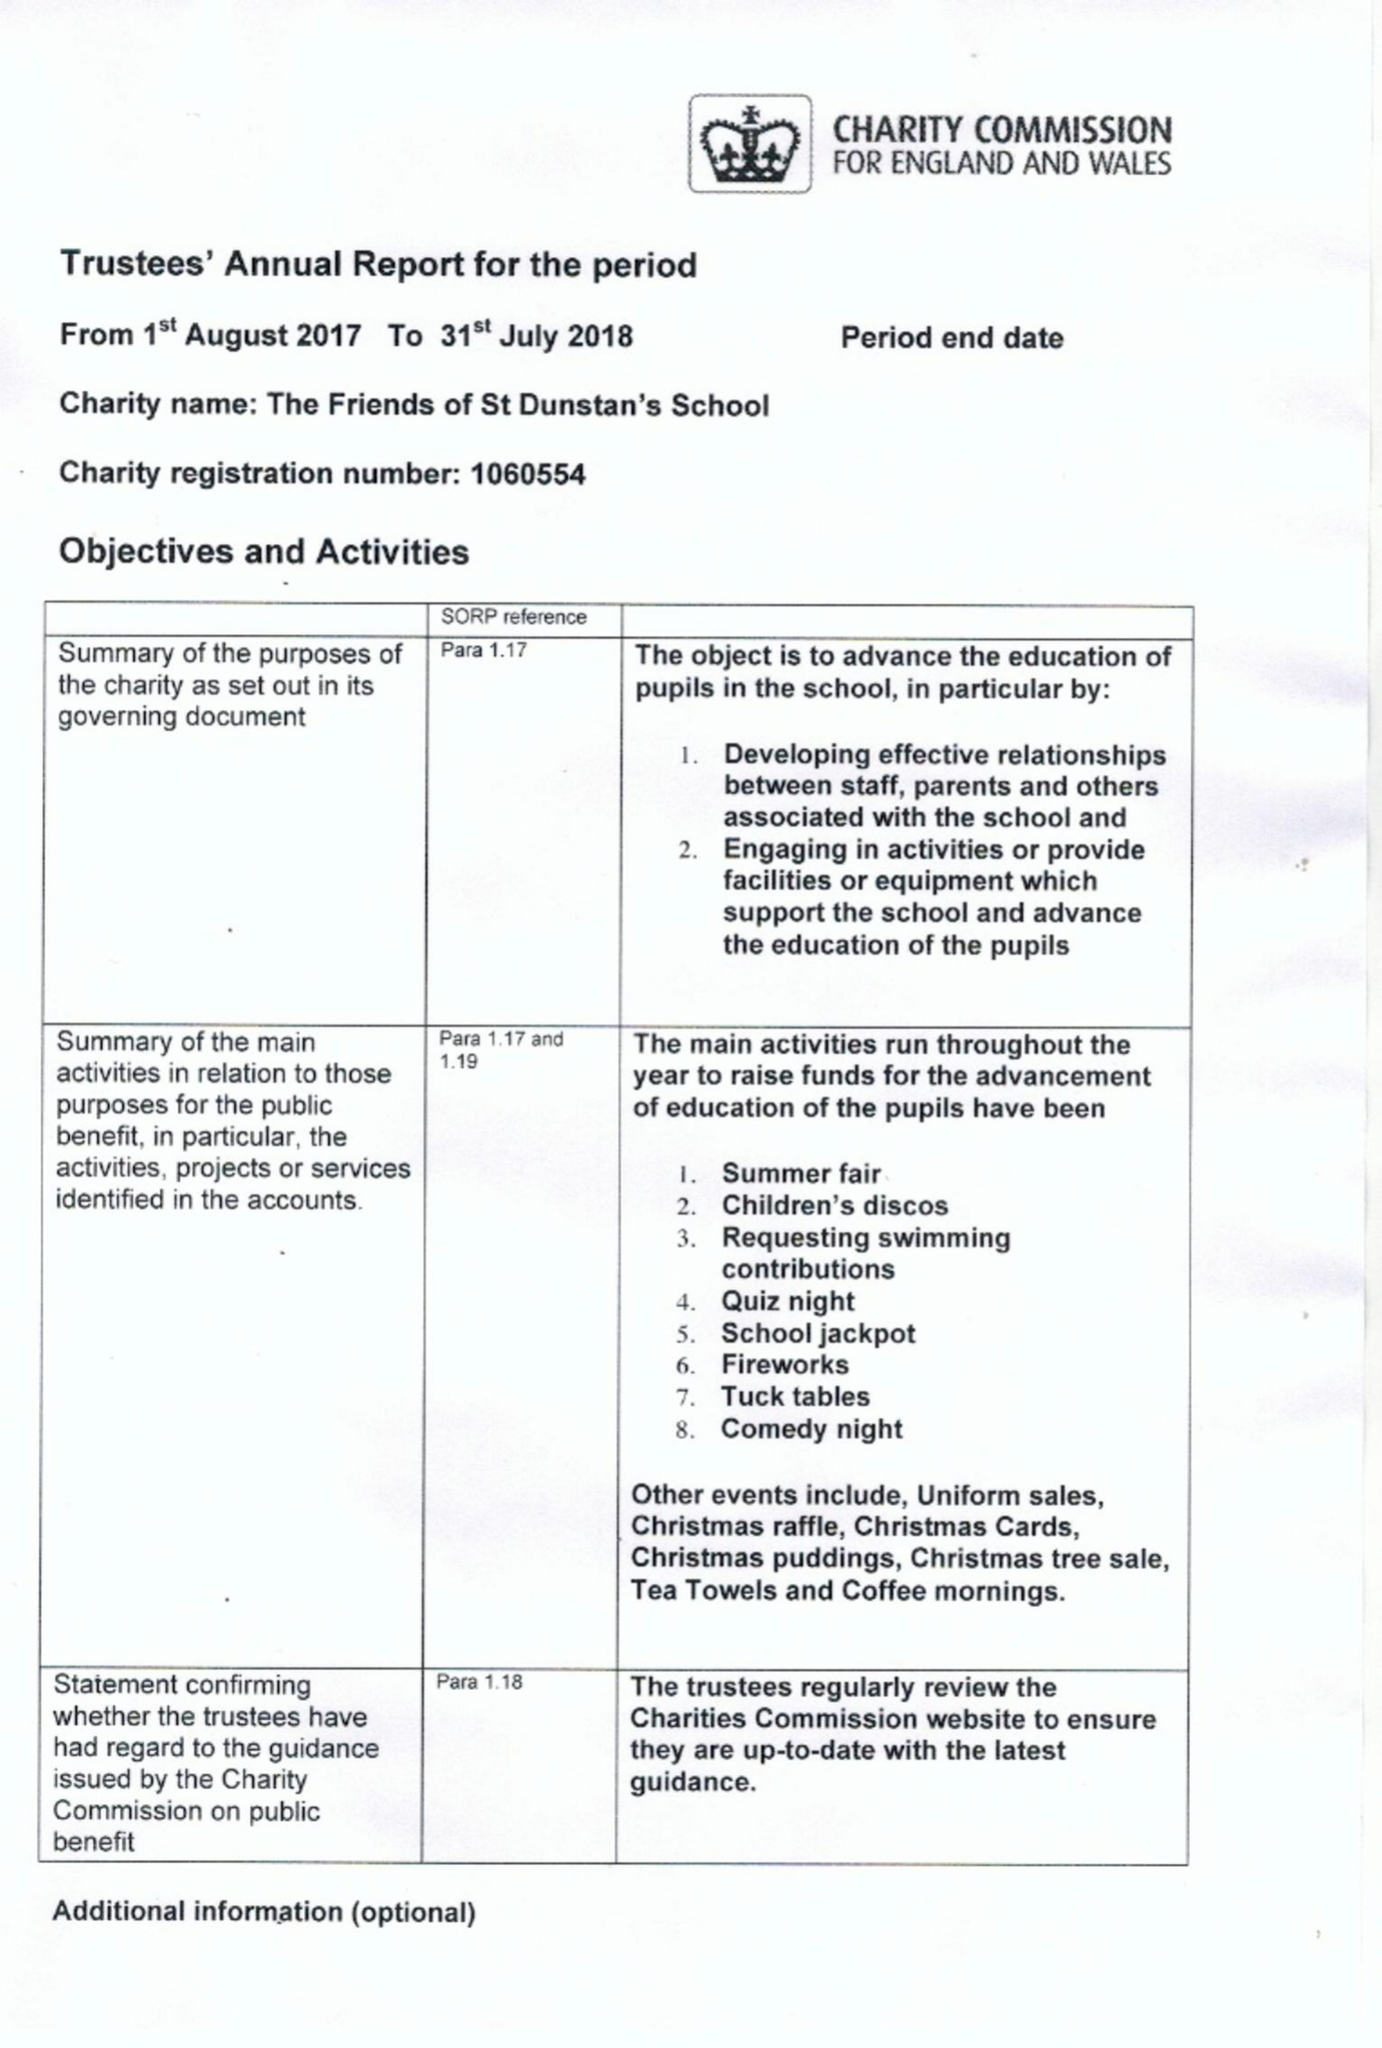What is the value for the address__street_line?
Answer the question using a single word or phrase. ONSLOW CRESCENT 